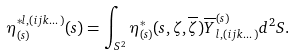<formula> <loc_0><loc_0><loc_500><loc_500>\eta _ { ( s ) } ^ { \ast l , ( i j k \dots ) } ( s ) = \int _ { S ^ { 2 } } \eta _ { ( s ) } ^ { \ast } ( s , \zeta , \overline { \zeta } ) \overline { Y } _ { l , ( i j k \dots ) } ^ { ( s ) } d ^ { 2 } S .</formula> 